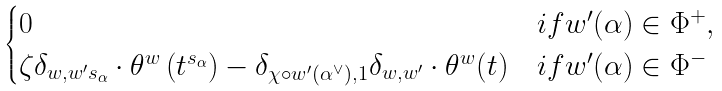<formula> <loc_0><loc_0><loc_500><loc_500>\begin{cases} 0 & i f w ^ { \prime } ( \alpha ) \in \Phi ^ { + } , \\ \zeta \delta _ { w , w ^ { \prime } s _ { \alpha } } \cdot \theta ^ { w } \left ( t ^ { s _ { \alpha } } \right ) - \delta _ { \chi \circ w ^ { \prime } ( \alpha ^ { \vee } ) , 1 } \delta _ { w , w ^ { \prime } } \cdot \theta ^ { w } ( t ) & i f w ^ { \prime } ( \alpha ) \in \Phi ^ { - } \end{cases}</formula> 